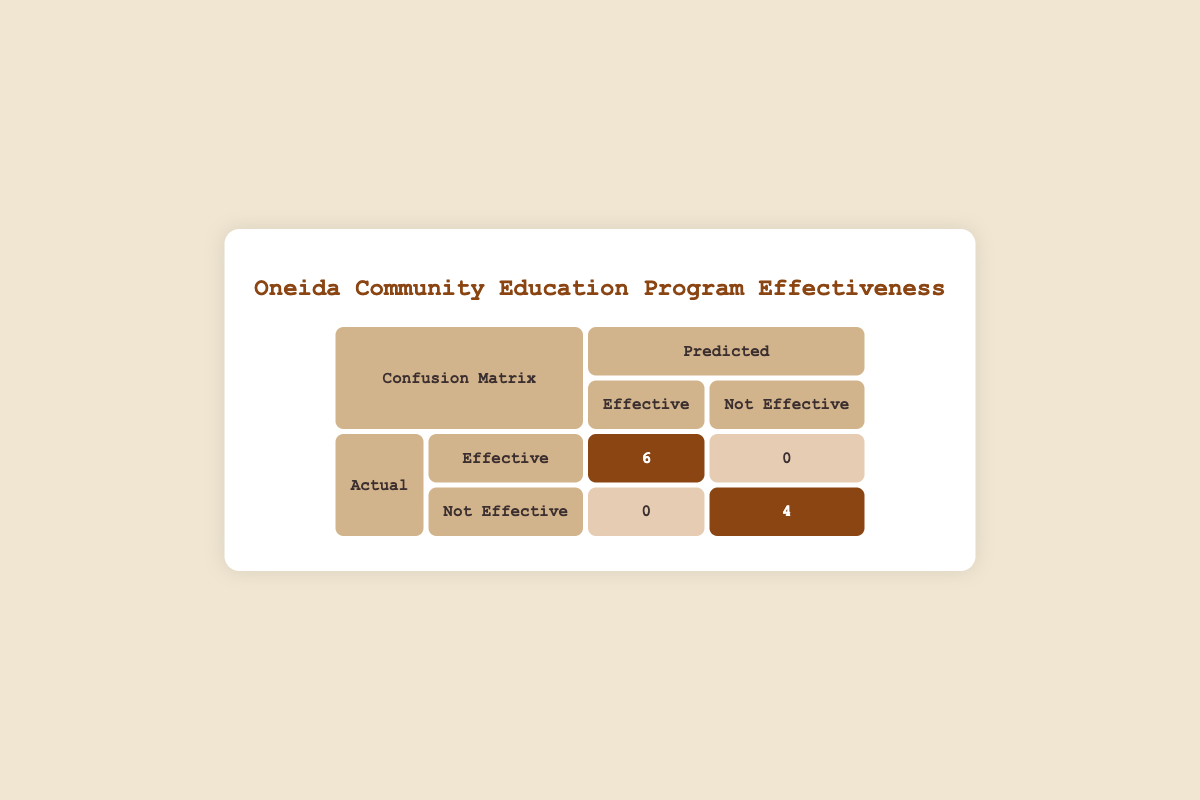What is the number of participants who were predicted to be effective? According to the confusion matrix table, the predicted effective category shows a total of 6 participants under the "Effective" row
Answer: 6 How many participants were actually not effective? The confusion matrix indicates that there are 4 participants in the "Not Effective" category on the actual side
Answer: 4 What is the total number of participants in the education program? There are 10 participants listed in the data set, which can be confirmed by counting the entries
Answer: 10 What is the number of false positives in the confusion matrix? The confusion matrix shows that there are 0 participants classified as false positives, which is under the "Not Effective" row and "Predicted Effective" column
Answer: 0 What is the total number of true negatives and how is it calculated? The true negatives are found in the confusion matrix under "Not Effective" (Actual) and "Not Effective" (Predicted), which equals 4. This is calculated by directly referring to the table
Answer: 4 Is there any participant who was predicted to be not effective but was actually effective? Yes, the confusion matrix shows a count of 0 in the "Not Effective" (Actual) and "Effective" (Predicted) section, indicating no participants fall into this category
Answer: No What is the total number of participants who showed improvement in their post-assessment scores? Based on the effective classification, 6 participants improved their scores, which are listed under the "Effective" actual category in the confusion matrix
Answer: 6 What percentage of participants were effective according to the confusion matrix? There were 6 effective participants out of 10 total participants, which can be calculated as (6/10) * 100 = 60%
Answer: 60% How many participants showed no improvement in their post-assessment scores? From the data, there are 4 participants classified as effectively not improving, which corresponds to those in the "Not Effective" actual category in the confusion matrix
Answer: 4 